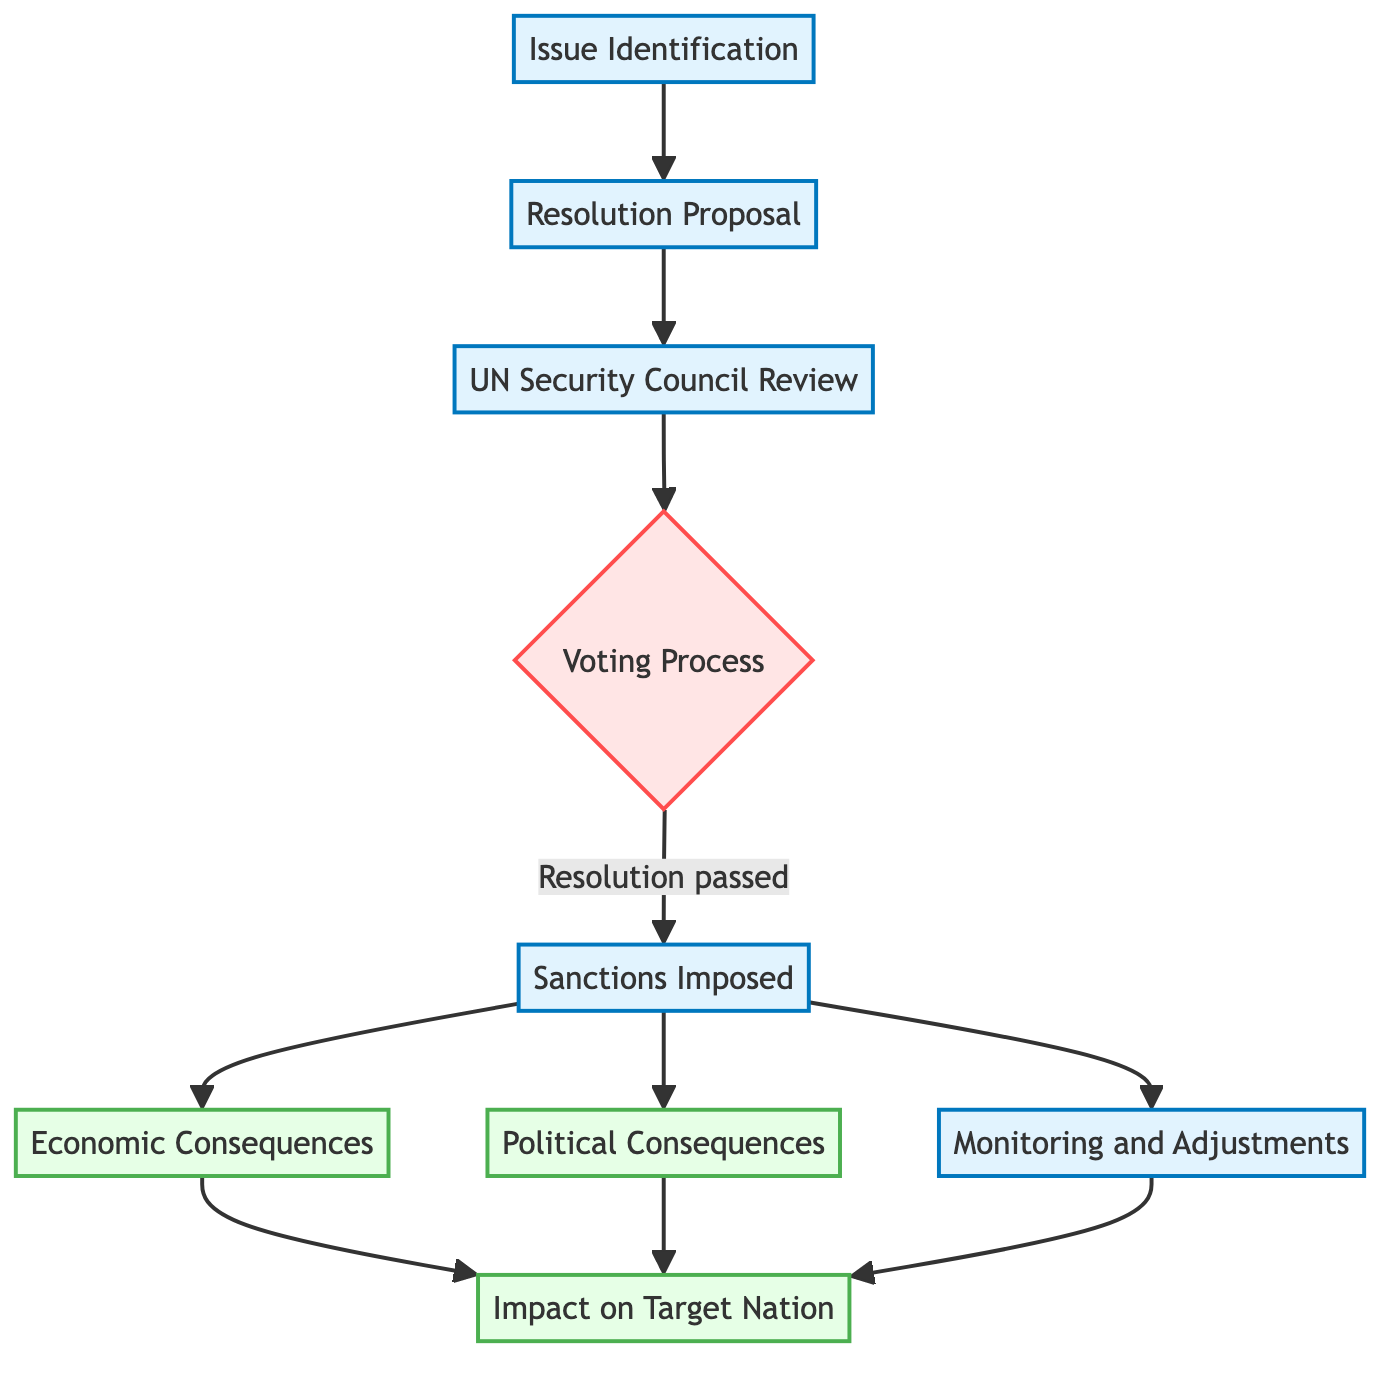What is the first step in the process of imposing sanctions? The diagram indicates that the first step is "Issue Identification," which is the starting point for the entire process.
Answer: Issue Identification How many consequences are shown in the flowchart? There are two distinct consequences shown: "Economic Consequences" and "Political Consequences."
Answer: 2 Which entity conducts the "Review" of the resolution proposal? The flowchart shows that the "UN Security Council" is responsible for reviewing the resolution proposal.
Answer: UN Security Council What happens if the resolution is passed? If the resolution is passed, it leads to the next step, which is "Sanctions Imposed," as indicated in the flow of the diagram.
Answer: Sanctions Imposed What is the final outcome of the sanctions process on the target nation? The final outcome is summarized as "Impact on Target Nation," reflecting the overall effect of both economic and political consequences.
Answer: Impact on Target Nation What step follows the "Sanctions Imposed"? According to the flowchart, the step that follows is "Monitoring and Adjustments," which is crucial for assessing the sanctions' effectiveness.
Answer: Monitoring and Adjustments Which step in the diagram involves making a decision? The "Voting Process" is the step where a decision is made, determining whether the resolution will pass or fail.
Answer: Voting Process What type of consequences are indicated after sanctions are imposed? Both “Economic Consequences” and “Political Consequences” are types of consequences indicated after sanctions are imposed in the flowchart.
Answer: Economic and Political Consequences What flows from "Monitoring and Adjustments"? Both “Economic Consequences” and “Political Consequences” flow from "Monitoring and Adjustments," as well as lead to "Impact on Target Nation."
Answer: Impact on Target Nation 